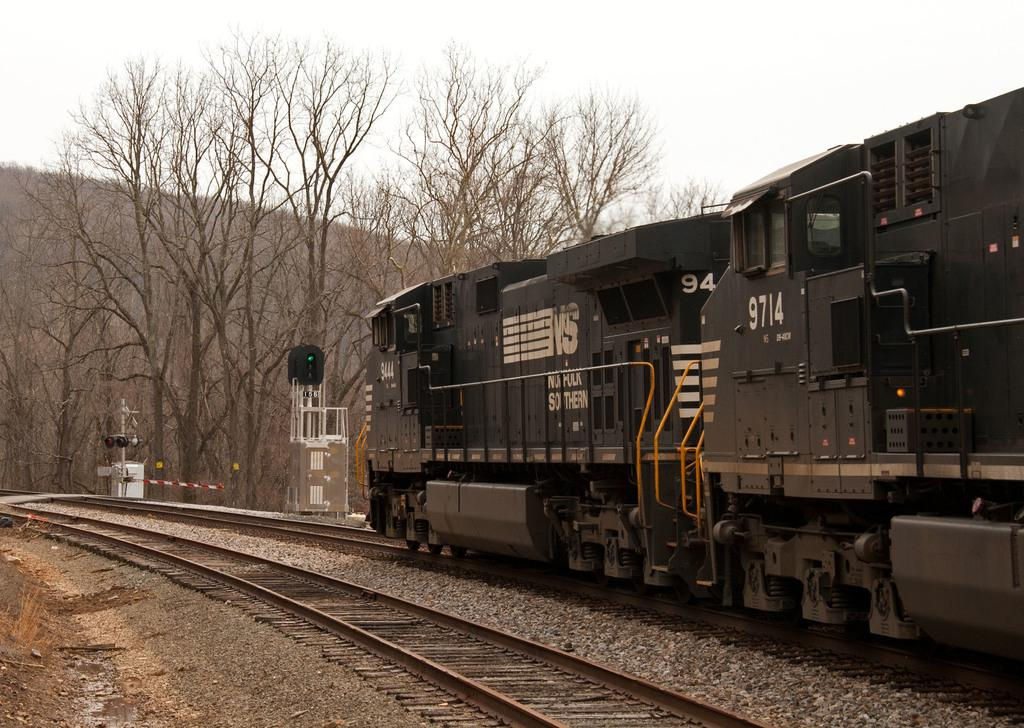What is the main subject of the image? The main subject of the image is a train. Where is the train located in the image? The train is on a railway track. What can be seen in the background of the image? There are trees and a hill visible in the image. Are there any other railway tracks in the image? Yes, there is another railway track in the image. How would you describe the weather in the image? The sky is cloudy in the image, suggesting overcast or potentially rainy weather. How many ghosts can be seen interacting with the train in the image? There are no ghosts present in the image; it features a train on a railway track with trees, a hill, and another railway track in the background. 